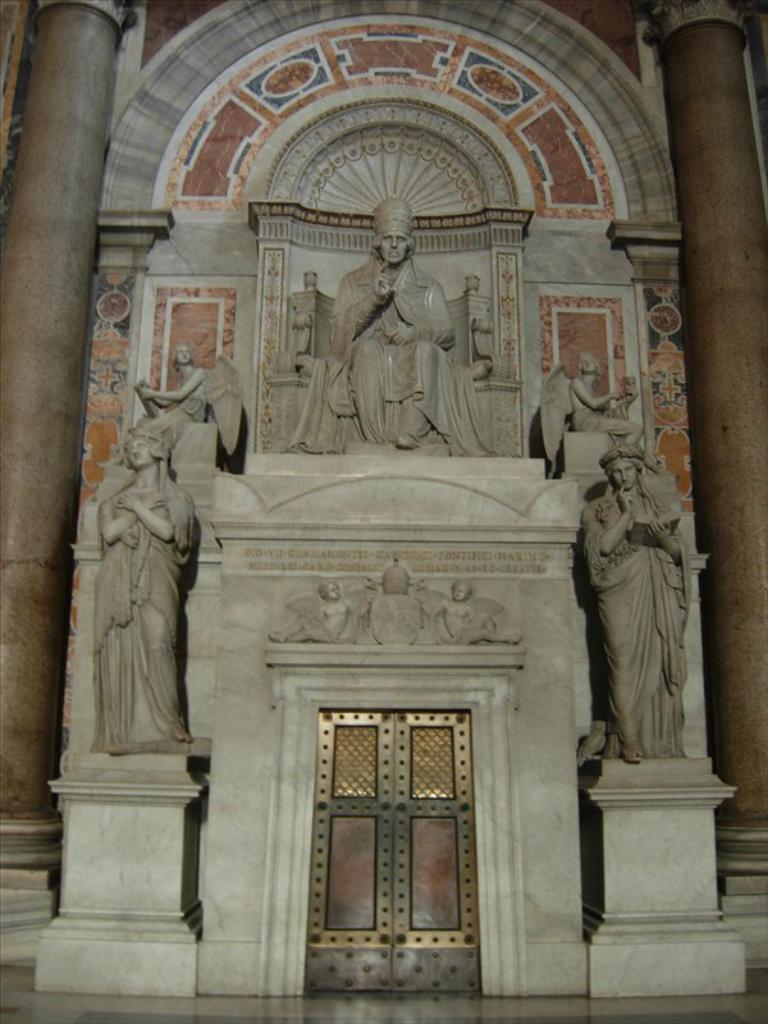Could you give a brief overview of what you see in this image? In this image we can see an interior of the building. There are many sculptures in the image. There is an arch and marble design in the image. 